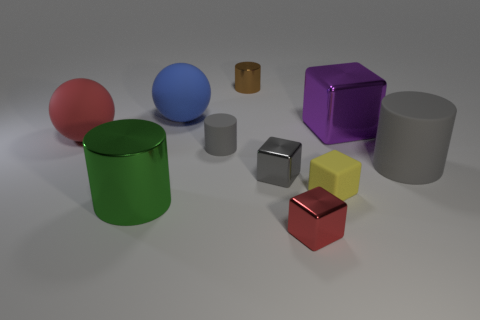Please describe the setting these objects are placed in. The objects are arranged on a flat, diffuse surface with a gentle gradient shading from light to dark, likely to be a virtual setup designed to focus attention on the objects themselves. 